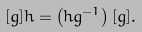Convert formula to latex. <formula><loc_0><loc_0><loc_500><loc_500>[ g ] h = \left ( h g ^ { - 1 } \right ) [ g ] .</formula> 